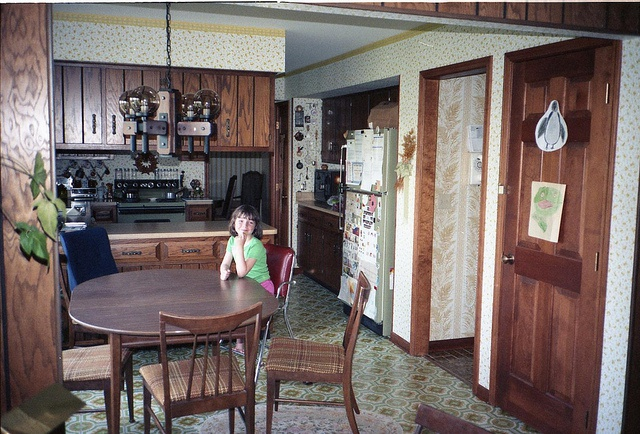Describe the objects in this image and their specific colors. I can see chair in white, maroon, gray, black, and darkgray tones, dining table in white, gray, maroon, and black tones, refrigerator in white, lightgray, darkgray, gray, and black tones, chair in white, gray, maroon, and darkgray tones, and potted plant in white, darkgray, gray, and tan tones in this image. 